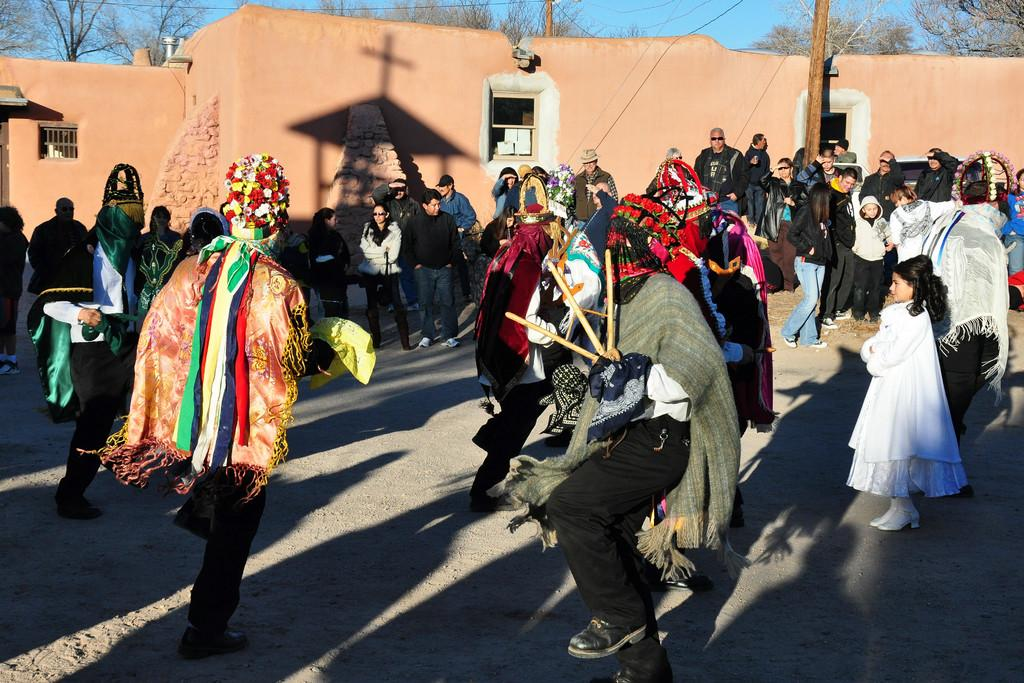How many people are in the image? There is a group of people in the image, but the exact number cannot be determined from the provided facts. What is located behind the group of people? There is a wall visible in the image. What can be seen on the wall? There is a shadow on the wall. What is visible behind the wall? Trees are visible behind the wall. What type of straw is sticking out of the water in the image? There is no water or straw present in the image. 